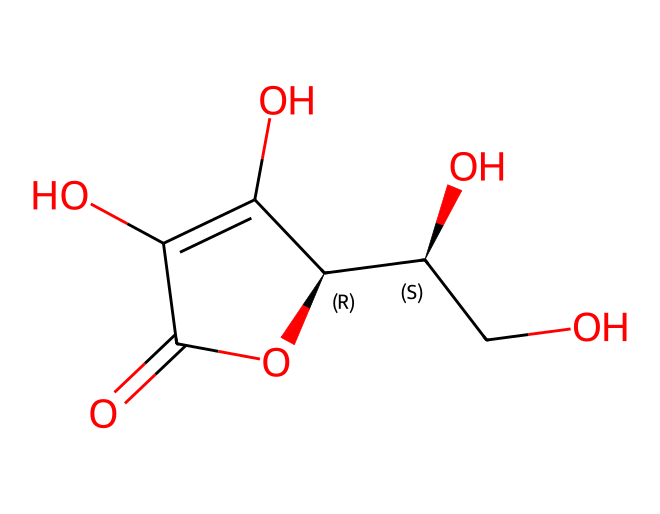What is the molecular formula of ascorbic acid? By analyzing the provided SMILES, we can deduce the molecular formula by counting the atoms of each element. In this structure, we identify 6 carbon (C) atoms, 8 hydrogen (H) atoms, and 6 oxygen (O) atoms. Therefore, the molecular formula is C6H8O6.
Answer: C6H8O6 How many hydroxyl (-OH) groups are present in ascorbic acid? Examining the structure reveals that there are two distinct -OH groups attached to carbon atoms, as indicated by the presence of oxygen connected to hydrogen atoms in the structure.
Answer: 2 What type of acid is ascorbic acid classified as? Ascorbic acid, commonly known as Vitamin C, is classified as an organic acid due to its carbon-based structure and carboxylic functional groups.
Answer: organic acid Does ascorbic acid have a cyclic structure? The SMILES notation and subsequent interpretation of the structure indicate the presence of a cyclic formation, notably a lactone, which is characteristic of ascorbic acid.
Answer: yes What functional groups are found in ascorbic acid? By analyzing the structural representation, we can identify that ascorbic acid contains both hydroxyl (-OH) and a carbonyl (C=O) functional groups, which contribute to its chemical behavior.
Answer: hydroxyl and carbonyl Is the ascorbic acid structure symmetrical? Upon examining the arrangement of atoms and bonds in the structure, we can see that it doesn't exhibit full symmetry due to the uneven distribution of functional groups and atom connections.
Answer: no 